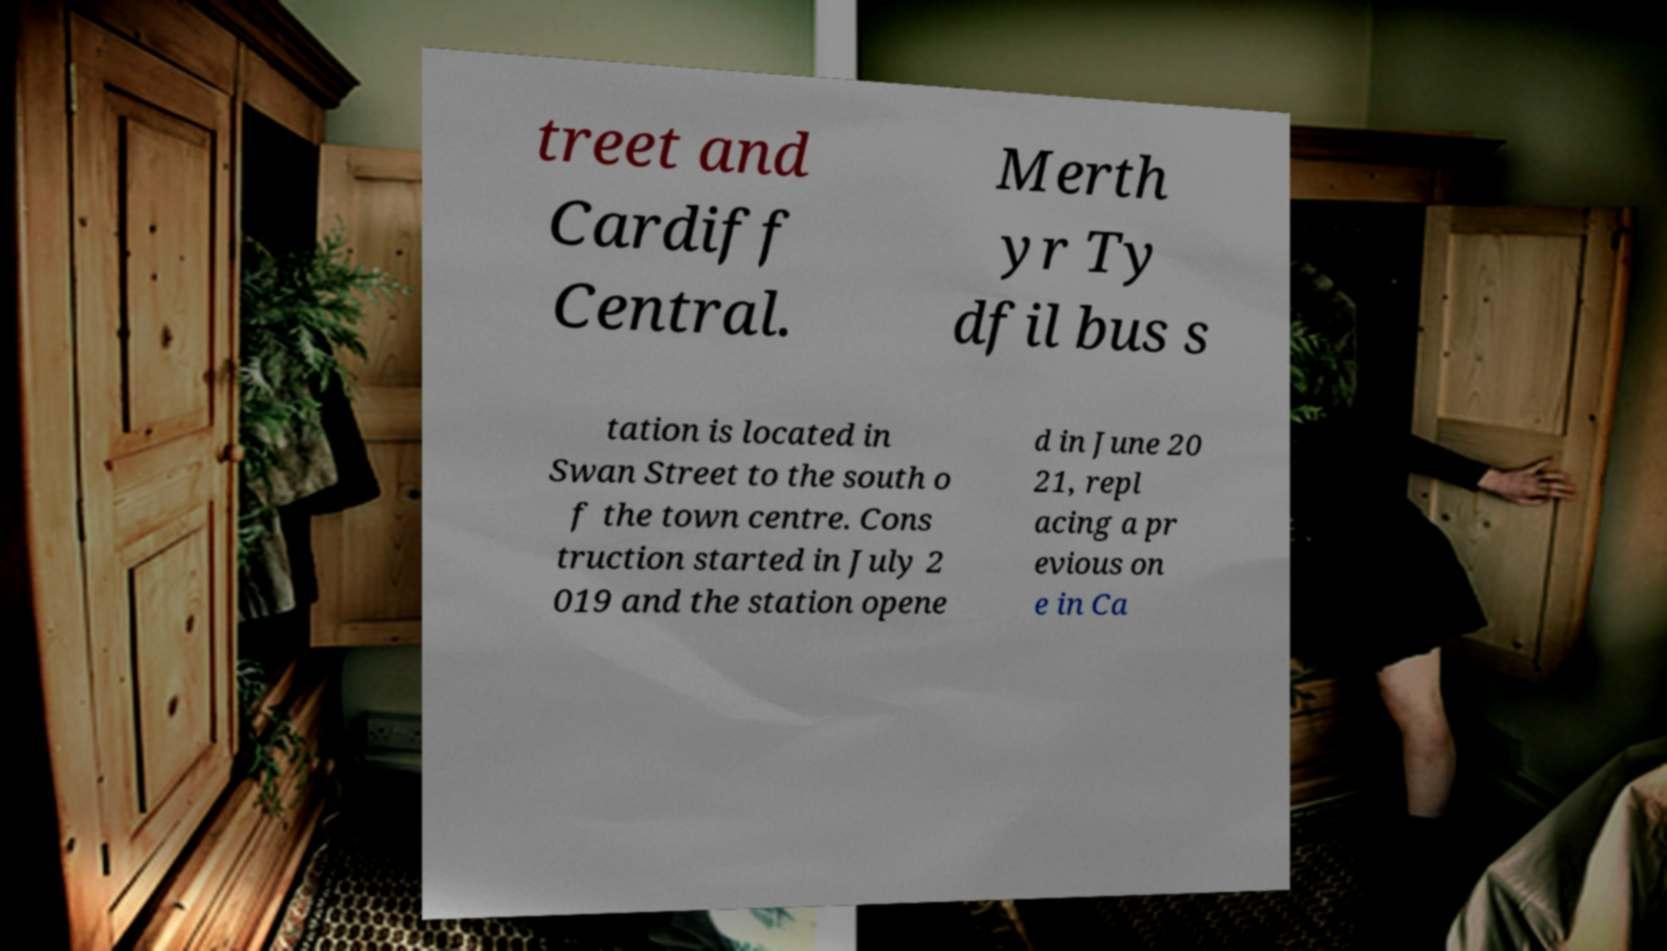Can you accurately transcribe the text from the provided image for me? treet and Cardiff Central. Merth yr Ty dfil bus s tation is located in Swan Street to the south o f the town centre. Cons truction started in July 2 019 and the station opene d in June 20 21, repl acing a pr evious on e in Ca 